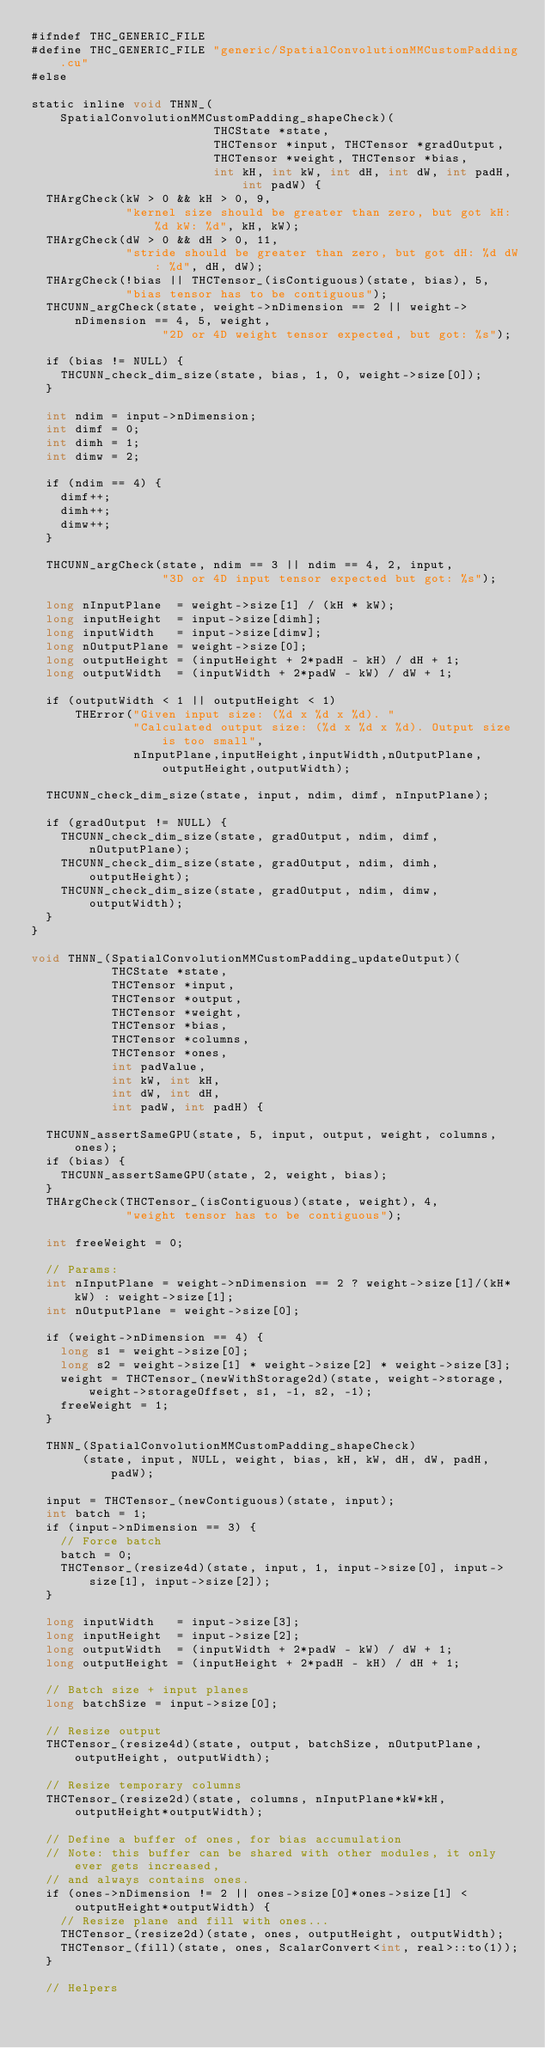Convert code to text. <code><loc_0><loc_0><loc_500><loc_500><_Cuda_>#ifndef THC_GENERIC_FILE
#define THC_GENERIC_FILE "generic/SpatialConvolutionMMCustomPadding.cu"
#else

static inline void THNN_(SpatialConvolutionMMCustomPadding_shapeCheck)(
                         THCState *state,
                         THCTensor *input, THCTensor *gradOutput,
                         THCTensor *weight, THCTensor *bias,
                         int kH, int kW, int dH, int dW, int padH, int padW) {
  THArgCheck(kW > 0 && kH > 0, 9,
             "kernel size should be greater than zero, but got kH: %d kW: %d", kH, kW);
  THArgCheck(dW > 0 && dH > 0, 11,
             "stride should be greater than zero, but got dH: %d dW: %d", dH, dW);
  THArgCheck(!bias || THCTensor_(isContiguous)(state, bias), 5,
             "bias tensor has to be contiguous");
  THCUNN_argCheck(state, weight->nDimension == 2 || weight->nDimension == 4, 5, weight,
                  "2D or 4D weight tensor expected, but got: %s");

  if (bias != NULL) {
    THCUNN_check_dim_size(state, bias, 1, 0, weight->size[0]);
  }

  int ndim = input->nDimension;
  int dimf = 0;
  int dimh = 1;
  int dimw = 2;

  if (ndim == 4) {
    dimf++;
    dimh++;
    dimw++;
  }

  THCUNN_argCheck(state, ndim == 3 || ndim == 4, 2, input,
                  "3D or 4D input tensor expected but got: %s");

  long nInputPlane  = weight->size[1] / (kH * kW);
  long inputHeight  = input->size[dimh];
  long inputWidth   = input->size[dimw];
  long nOutputPlane = weight->size[0];
  long outputHeight = (inputHeight + 2*padH - kH) / dH + 1;
  long outputWidth  = (inputWidth + 2*padW - kW) / dW + 1;

  if (outputWidth < 1 || outputHeight < 1)
      THError("Given input size: (%d x %d x %d). "
              "Calculated output size: (%d x %d x %d). Output size is too small",
              nInputPlane,inputHeight,inputWidth,nOutputPlane,outputHeight,outputWidth);

  THCUNN_check_dim_size(state, input, ndim, dimf, nInputPlane);

  if (gradOutput != NULL) {
    THCUNN_check_dim_size(state, gradOutput, ndim, dimf, nOutputPlane);
    THCUNN_check_dim_size(state, gradOutput, ndim, dimh, outputHeight);
    THCUNN_check_dim_size(state, gradOutput, ndim, dimw, outputWidth);
  }
}

void THNN_(SpatialConvolutionMMCustomPadding_updateOutput)(
           THCState *state,
           THCTensor *input,
           THCTensor *output,
           THCTensor *weight,
           THCTensor *bias,
           THCTensor *columns,
           THCTensor *ones,
           int padValue,
           int kW, int kH,
           int dW, int dH,
           int padW, int padH) {

  THCUNN_assertSameGPU(state, 5, input, output, weight, columns, ones);
  if (bias) {
    THCUNN_assertSameGPU(state, 2, weight, bias);
  }
  THArgCheck(THCTensor_(isContiguous)(state, weight), 4,
             "weight tensor has to be contiguous");

  int freeWeight = 0;

  // Params:
  int nInputPlane = weight->nDimension == 2 ? weight->size[1]/(kH*kW) : weight->size[1];
  int nOutputPlane = weight->size[0];

  if (weight->nDimension == 4) {
    long s1 = weight->size[0];
    long s2 = weight->size[1] * weight->size[2] * weight->size[3];
    weight = THCTensor_(newWithStorage2d)(state, weight->storage, weight->storageOffset, s1, -1, s2, -1);
    freeWeight = 1;
  }

  THNN_(SpatialConvolutionMMCustomPadding_shapeCheck)
       (state, input, NULL, weight, bias, kH, kW, dH, dW, padH, padW);

  input = THCTensor_(newContiguous)(state, input);
  int batch = 1;
  if (input->nDimension == 3) {
    // Force batch
    batch = 0;
    THCTensor_(resize4d)(state, input, 1, input->size[0], input->size[1], input->size[2]);
  }

  long inputWidth   = input->size[3];
  long inputHeight  = input->size[2];
  long outputWidth  = (inputWidth + 2*padW - kW) / dW + 1;
  long outputHeight = (inputHeight + 2*padH - kH) / dH + 1;

  // Batch size + input planes
  long batchSize = input->size[0];

  // Resize output
  THCTensor_(resize4d)(state, output, batchSize, nOutputPlane, outputHeight, outputWidth);

  // Resize temporary columns
  THCTensor_(resize2d)(state, columns, nInputPlane*kW*kH, outputHeight*outputWidth);

  // Define a buffer of ones, for bias accumulation
  // Note: this buffer can be shared with other modules, it only ever gets increased,
  // and always contains ones.
  if (ones->nDimension != 2 || ones->size[0]*ones->size[1] < outputHeight*outputWidth) {
    // Resize plane and fill with ones...
    THCTensor_(resize2d)(state, ones, outputHeight, outputWidth);
    THCTensor_(fill)(state, ones, ScalarConvert<int, real>::to(1));
  }

  // Helpers</code> 